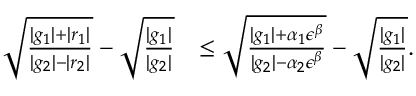<formula> <loc_0><loc_0><loc_500><loc_500>\begin{array} { r l } { \sqrt { \frac { | g _ { 1 } | + | r _ { 1 } | } { | g _ { 2 } | - | r _ { 2 } | } } - \sqrt { \frac { | g _ { 1 } | } { | g _ { 2 } | } } } & { \leq \sqrt { \frac { | g _ { 1 } | + \alpha _ { 1 } \epsilon ^ { \beta } } { | g _ { 2 } | - \alpha _ { 2 } \epsilon ^ { \beta } } } - \sqrt { \frac { | g _ { 1 } | } { | g _ { 2 } | } } . } \end{array}</formula> 